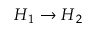Convert formula to latex. <formula><loc_0><loc_0><loc_500><loc_500>H _ { 1 } \to H _ { 2 }</formula> 